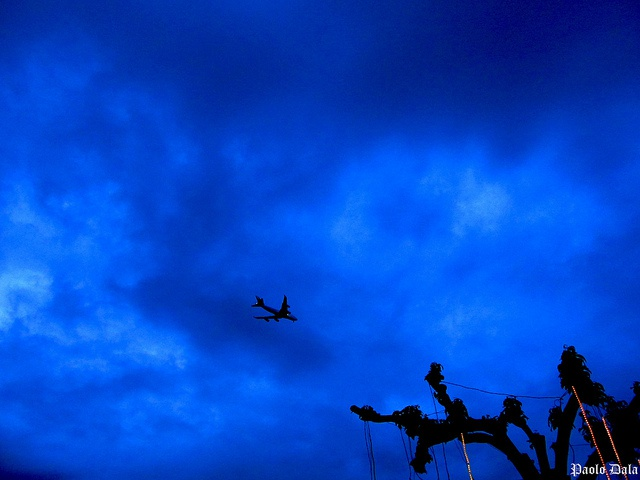Describe the objects in this image and their specific colors. I can see a airplane in darkblue, black, navy, and blue tones in this image. 